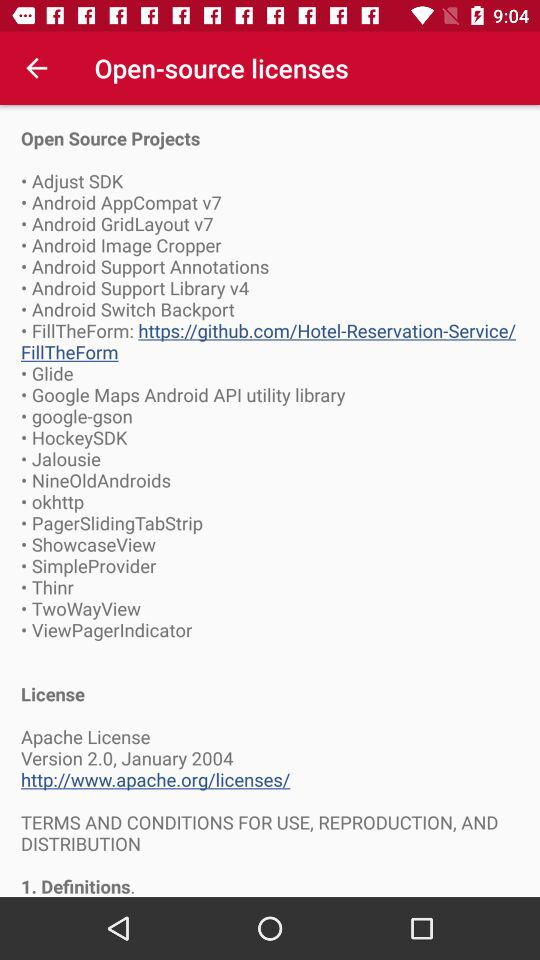What is the version of the application being used? The version of the application is 2.0. 